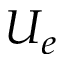Convert formula to latex. <formula><loc_0><loc_0><loc_500><loc_500>U _ { e }</formula> 